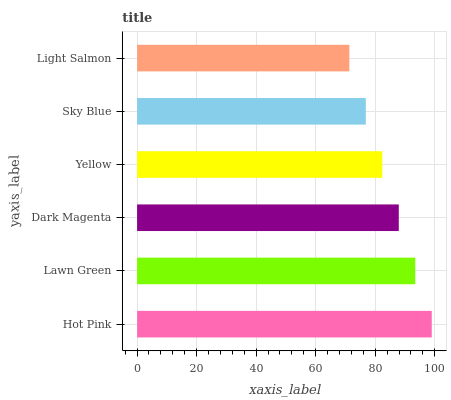Is Light Salmon the minimum?
Answer yes or no. Yes. Is Hot Pink the maximum?
Answer yes or no. Yes. Is Lawn Green the minimum?
Answer yes or no. No. Is Lawn Green the maximum?
Answer yes or no. No. Is Hot Pink greater than Lawn Green?
Answer yes or no. Yes. Is Lawn Green less than Hot Pink?
Answer yes or no. Yes. Is Lawn Green greater than Hot Pink?
Answer yes or no. No. Is Hot Pink less than Lawn Green?
Answer yes or no. No. Is Dark Magenta the high median?
Answer yes or no. Yes. Is Yellow the low median?
Answer yes or no. Yes. Is Lawn Green the high median?
Answer yes or no. No. Is Light Salmon the low median?
Answer yes or no. No. 